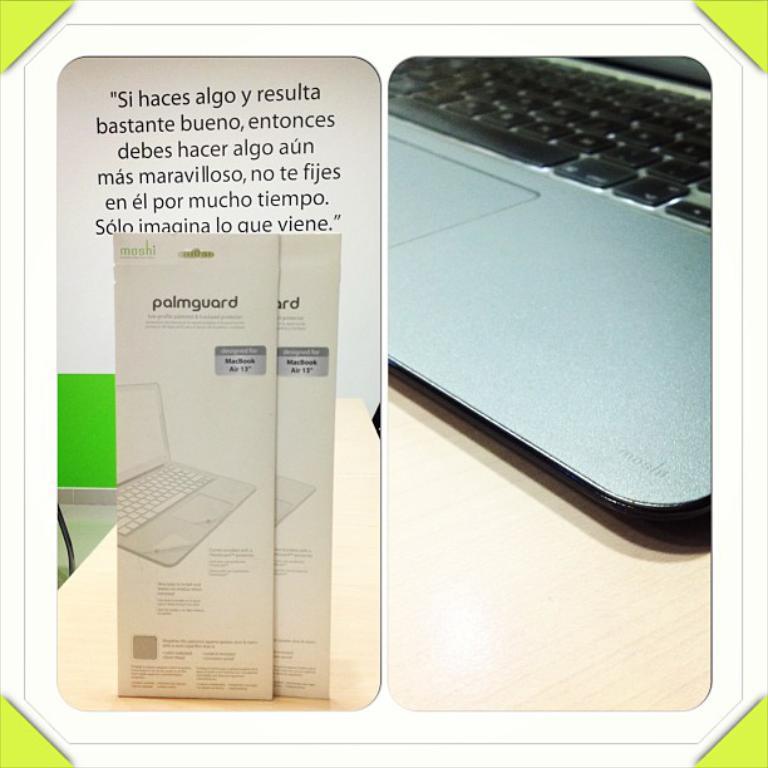What is the pamphlet for?
Your answer should be compact. Palmguard. 